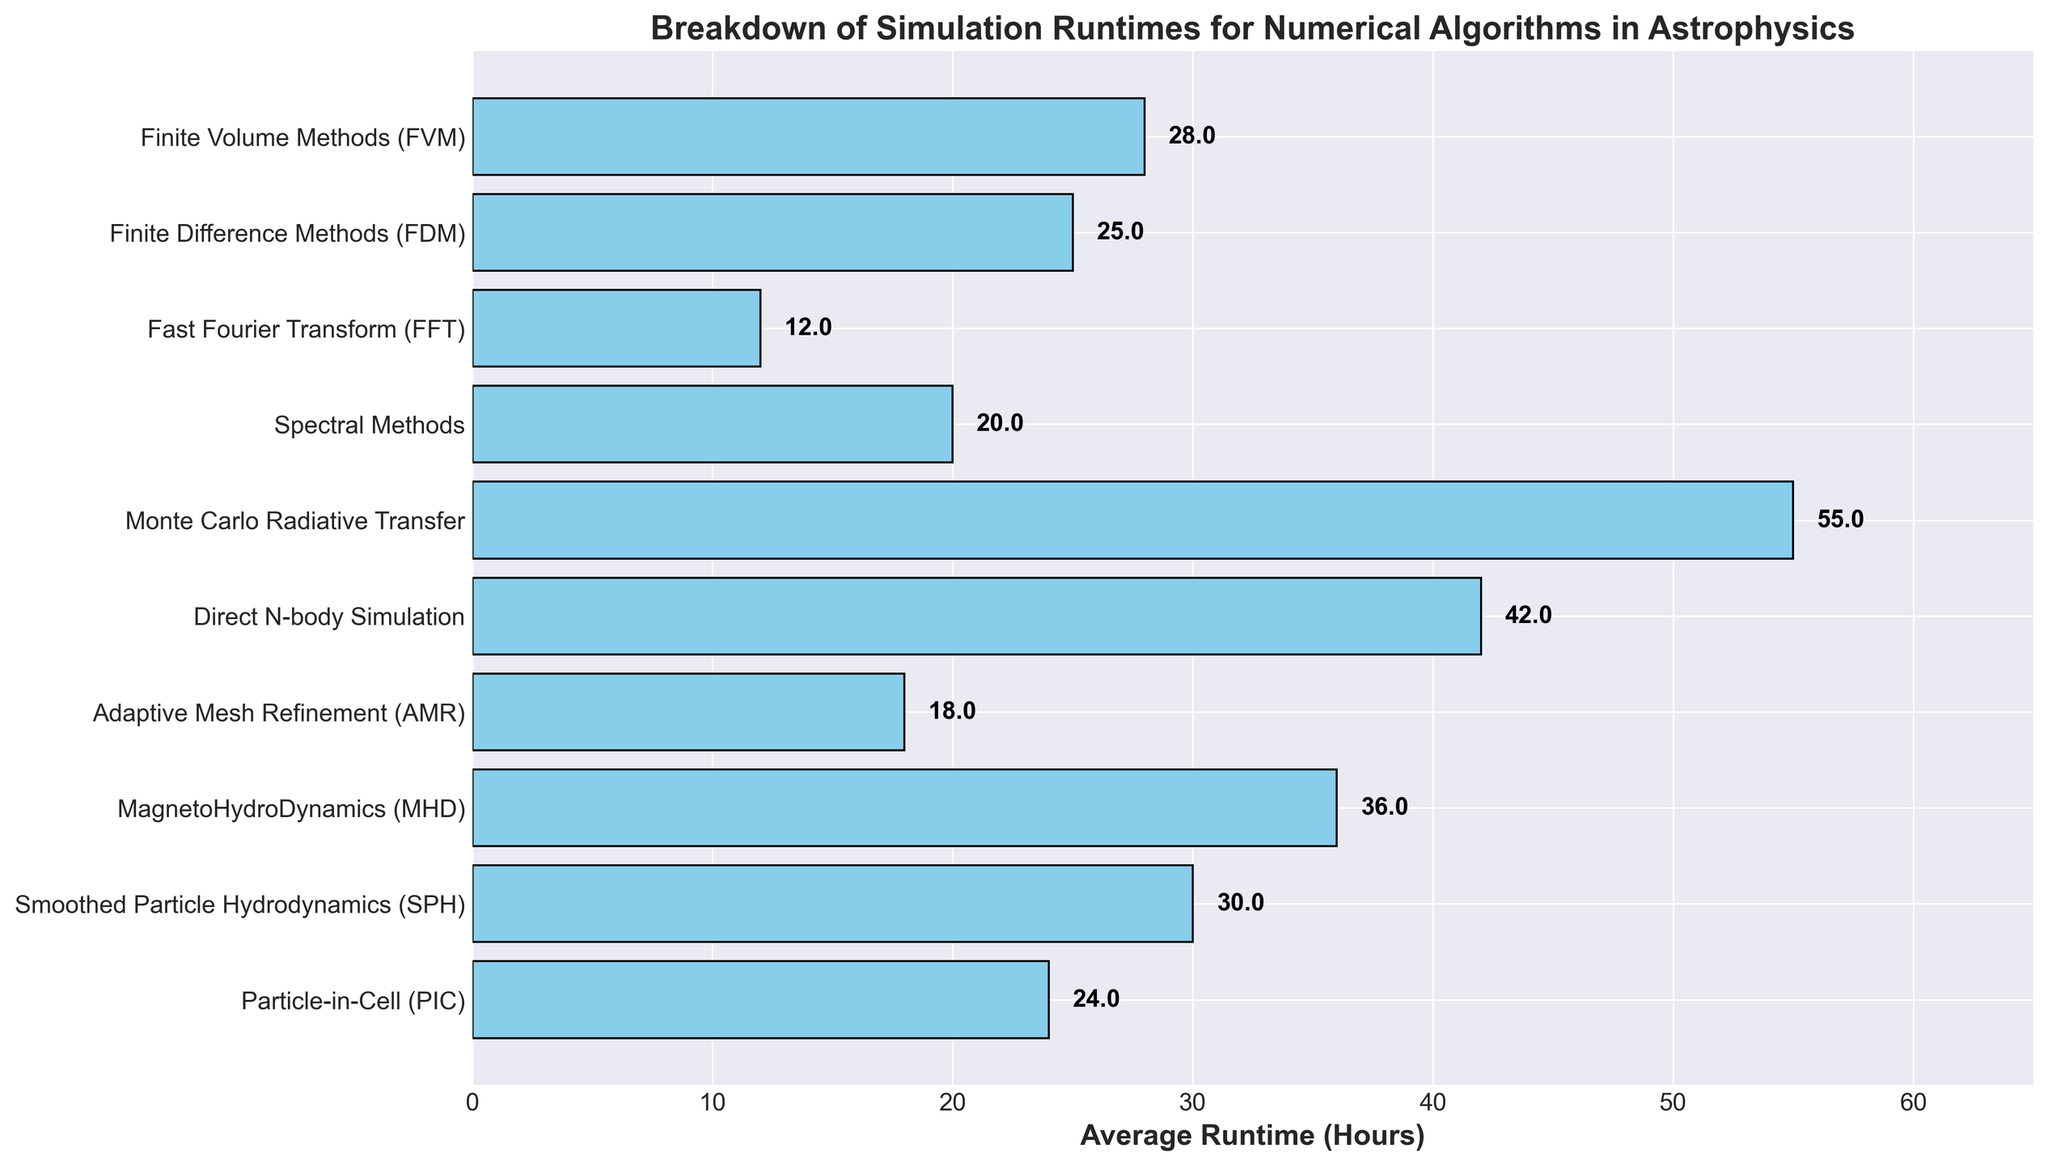What is the algorithm with the longest average runtime? By observing the length of the bars, the Monte Carlo Radiative Transfer algorithm has the longest bar, indicating it has the highest average runtime.
Answer: Monte Carlo Radiative Transfer Which algorithm has a shorter average runtime: Finite Difference Methods (FDM) or Finite Volume Methods (FVM)? By comparing the lengths of the bars, the bar for Finite Difference Methods (FDM) is slightly longer than Finite Volume Methods (FVM), indicating FDM has a higher average runtime. Therefore, FVM has a shorter average runtime.
Answer: Finite Volume Methods (FVM) What is the difference in average runtime between Smoothed Particle Hydrodynamics (SPH) and Fast Fourier Transform (FFT)? The average runtime for SPH is 30 hours and for FFT is 12 hours. The difference can be calculated as 30 - 12 = 18 hours.
Answer: 18 hours Which two algorithms have the closest average runtimes, and what is the difference between them? By visually comparing the bars, Finite Difference Methods (FDM) at 25 hours and Finite Volume Methods (FVM) at 28 hours have the closest lengths. The difference in their average runtimes is 28 - 25 = 3 hours.
Answer: Finite Difference Methods (FDM) and Finite Volume Methods (FVM); 3 hours What is the total average runtime for Particle-in-Cell (PIC), Smoothed Particle Hydrodynamics (SPH), and MagnetoHydroDynamics (MHD)? The average runtimes are 24 hours for PIC, 30 hours for SPH, and 36 hours for MHD. Summing these up, 24 + 30 + 36 = 90 hours.
Answer: 90 hours How much longer, on average, is the runtime for Direct N-body Simulation compared to Adaptive Mesh Refinement (AMR)? The average runtime for Direct N-body Simulation is 42 hours, and for AMR, it is 18 hours. The difference is 42 - 18 = 24 hours.
Answer: 24 hours What is the median average runtime of all the algorithms? To find the median, first list the average runtimes in ascending order: 12, 18, 20, 24, 25, 28, 30, 36, 42, 55. The median value, being the middle one in this ordered list, is the average of the 5th and 6th values: (25 + 28)/2 = 26.5 hours.
Answer: 26.5 hours What is the average runtime of the algorithms that are less than 30 hours? The average runtimes less than 30 hours are 12 (FFT), 18 (AMR), 20 (Spectral Methods), 24 (PIC), and 25 (FDM). Summing these up: 12 + 18 + 20 + 24 + 25 = 99 hours. The average is 99/5 = 19.8 hours.
Answer: 19.8 hours 